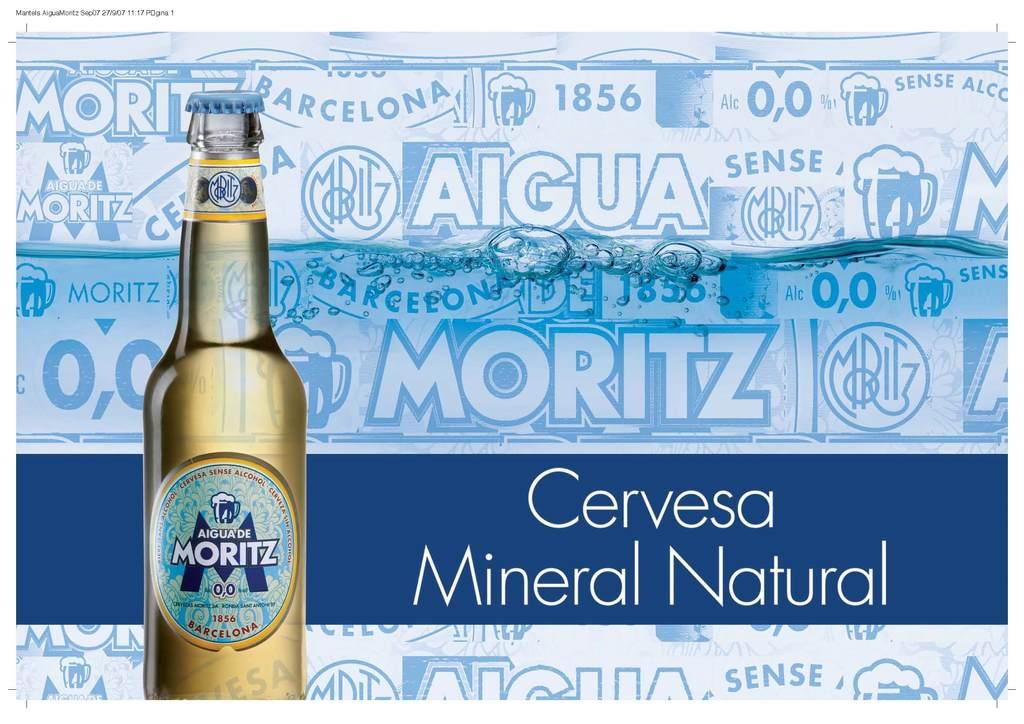<image>
Describe the image concisely. A bottle of Aigua de Moritz is displayed in an ad. 